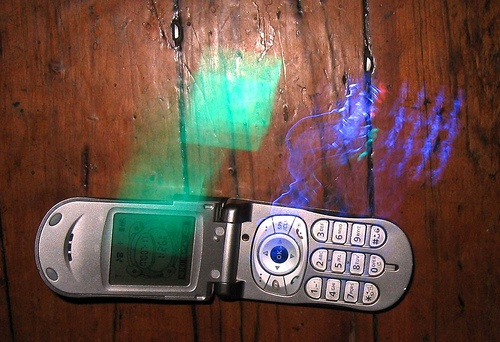Describe the objects in this image and their specific colors. I can see dining table in maroon, black, brown, and gray tones and cell phone in maroon, black, gray, darkgray, and lavender tones in this image. 